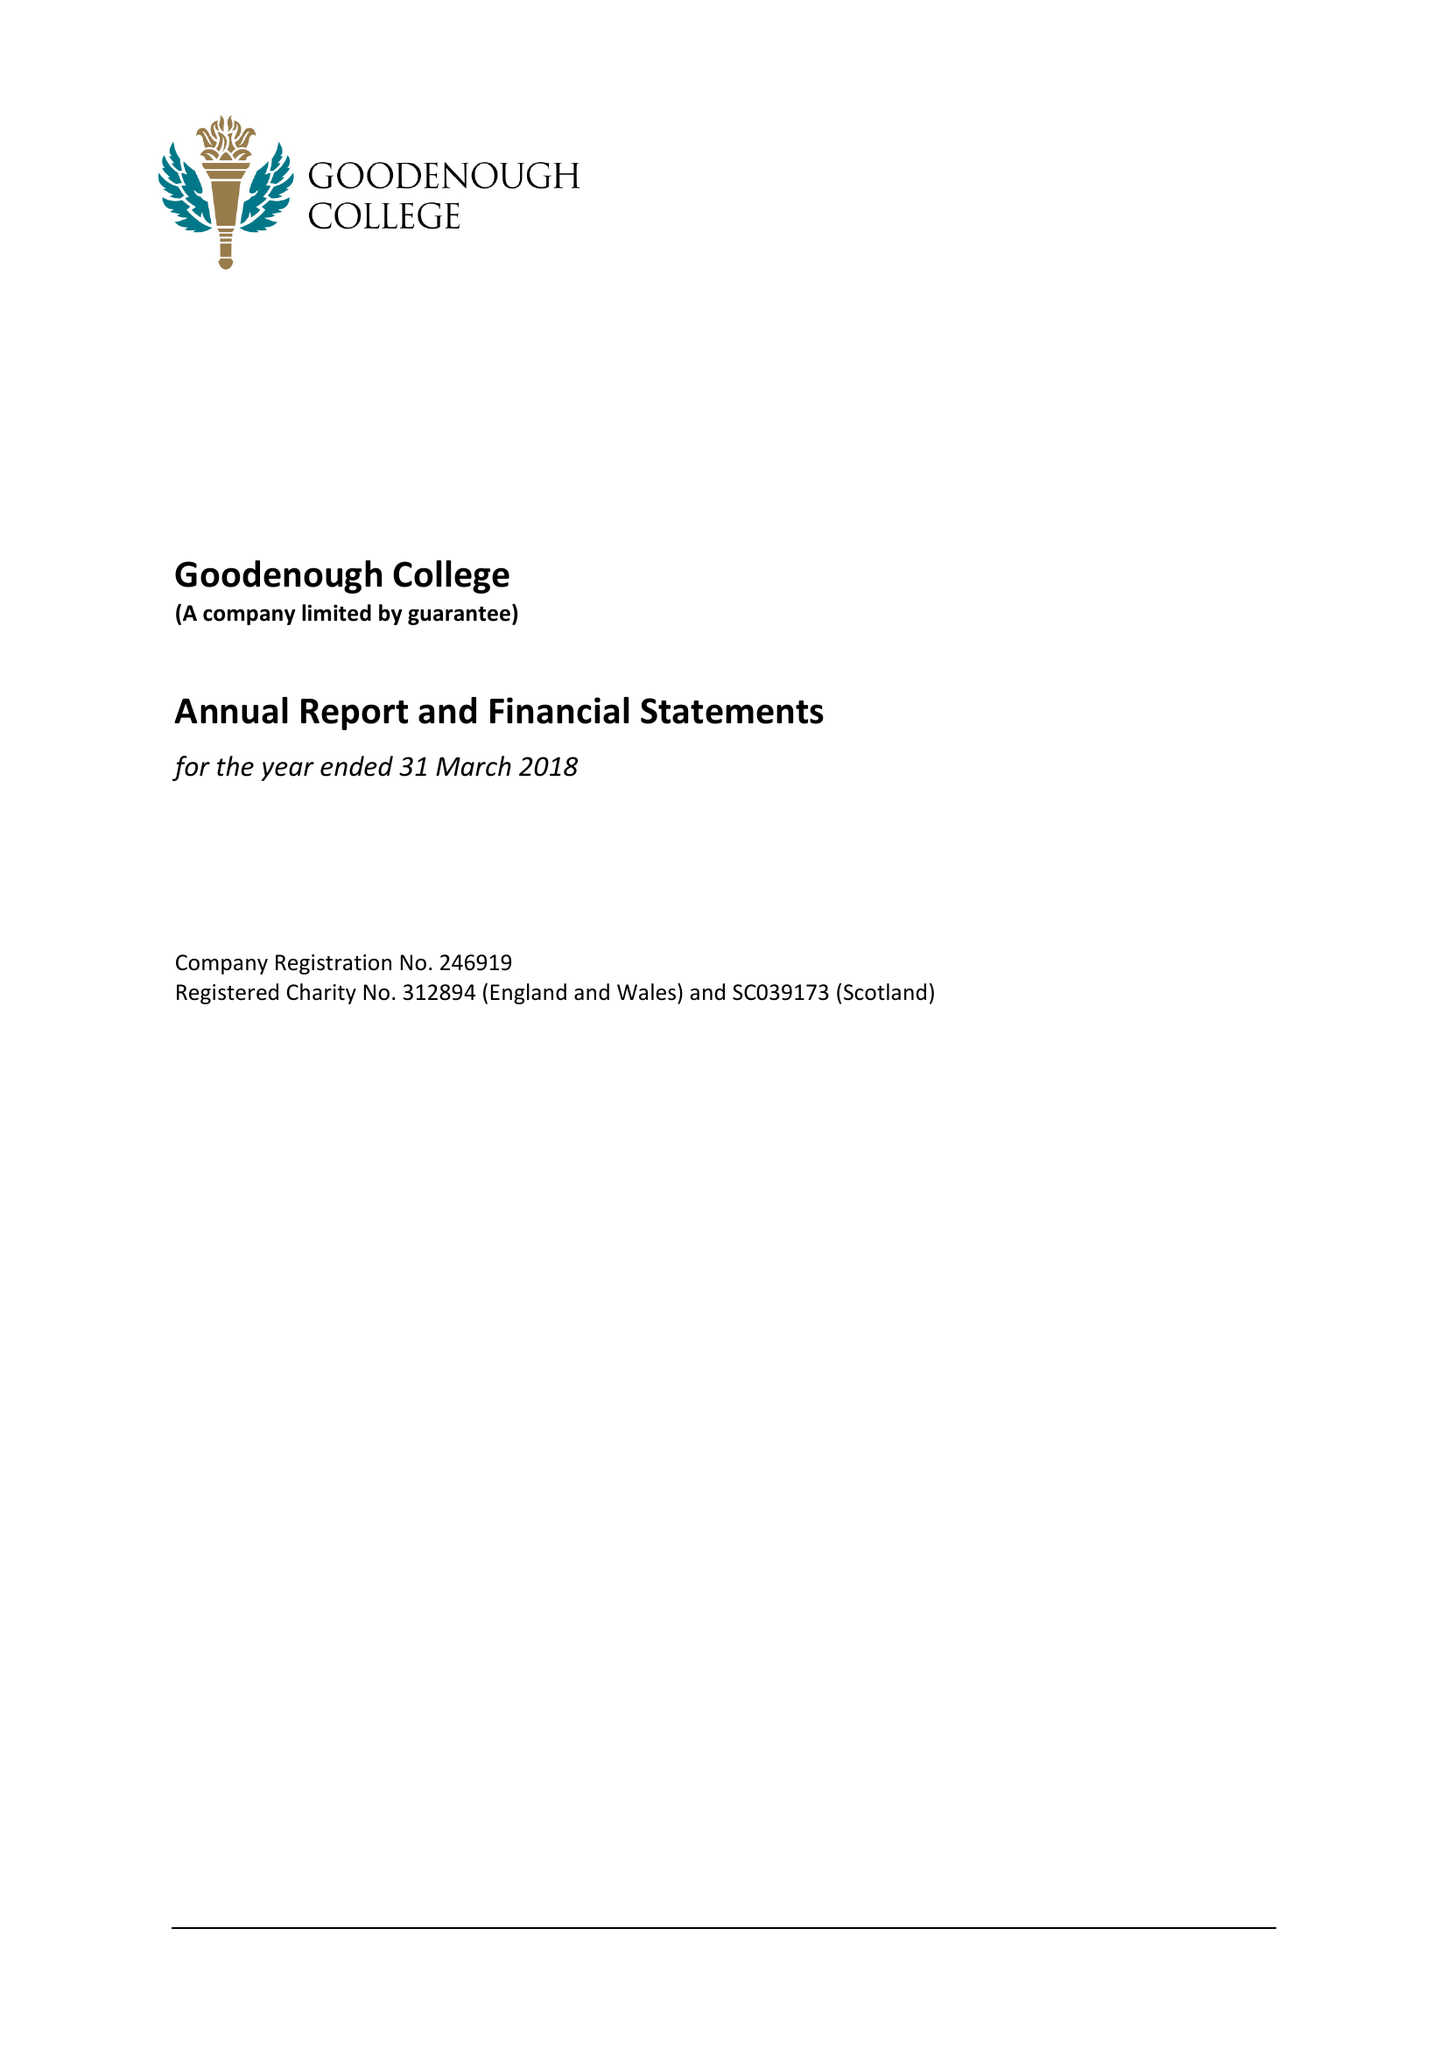What is the value for the charity_name?
Answer the question using a single word or phrase. Goodenough College 